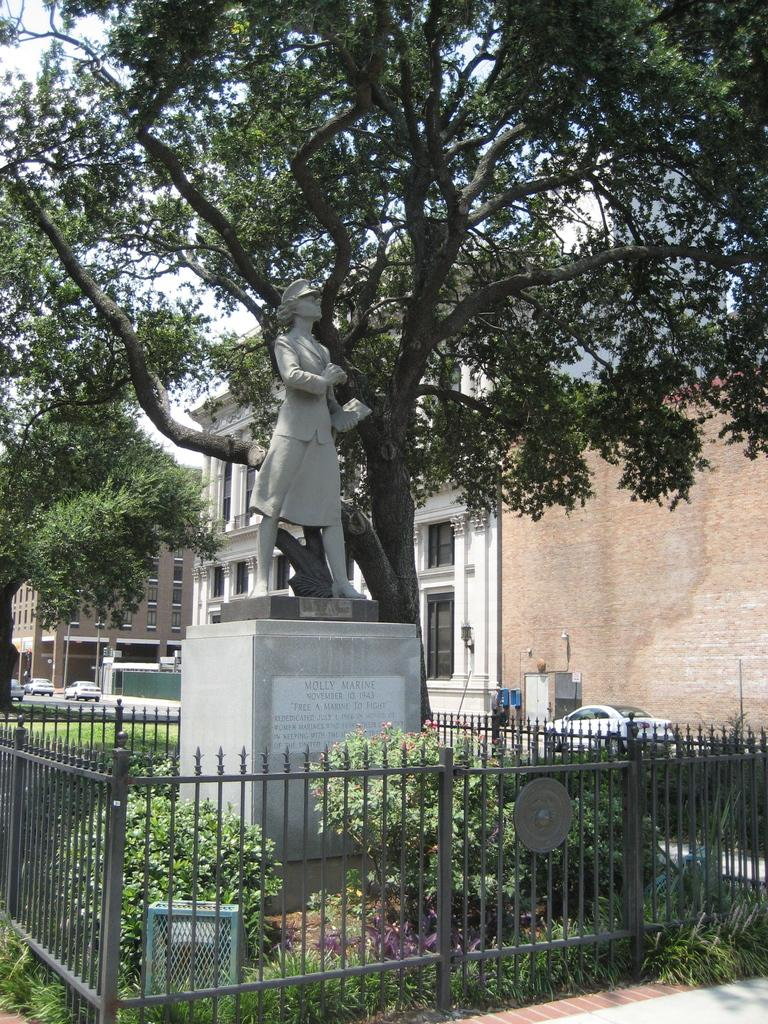<image>
Describe the image concisely. A statue of a woman whose name on the statue is Molly Marine surrounded by fencing. 